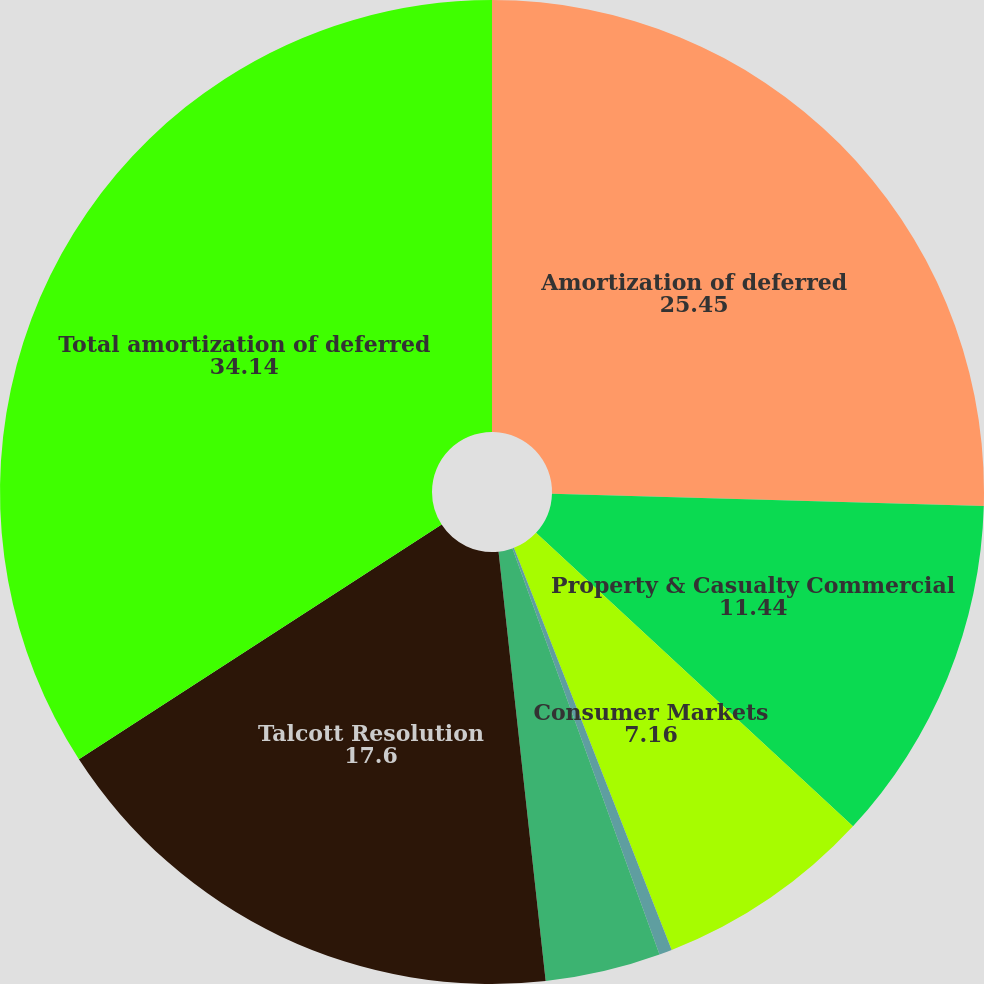Convert chart to OTSL. <chart><loc_0><loc_0><loc_500><loc_500><pie_chart><fcel>Amortization of deferred<fcel>Property & Casualty Commercial<fcel>Consumer Markets<fcel>Group Benefits<fcel>Mutual Funds<fcel>Talcott Resolution<fcel>Total amortization of deferred<nl><fcel>25.45%<fcel>11.44%<fcel>7.16%<fcel>0.42%<fcel>3.79%<fcel>17.6%<fcel>34.14%<nl></chart> 